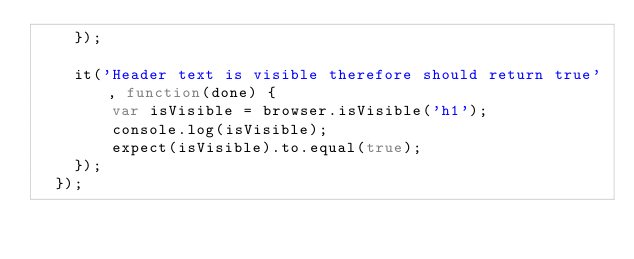Convert code to text. <code><loc_0><loc_0><loc_500><loc_500><_JavaScript_>    });
  
    it('Header text is visible therefore should return true', function(done) {
        var isVisible = browser.isVisible('h1');
        console.log(isVisible);
        expect(isVisible).to.equal(true);
    });
  });</code> 